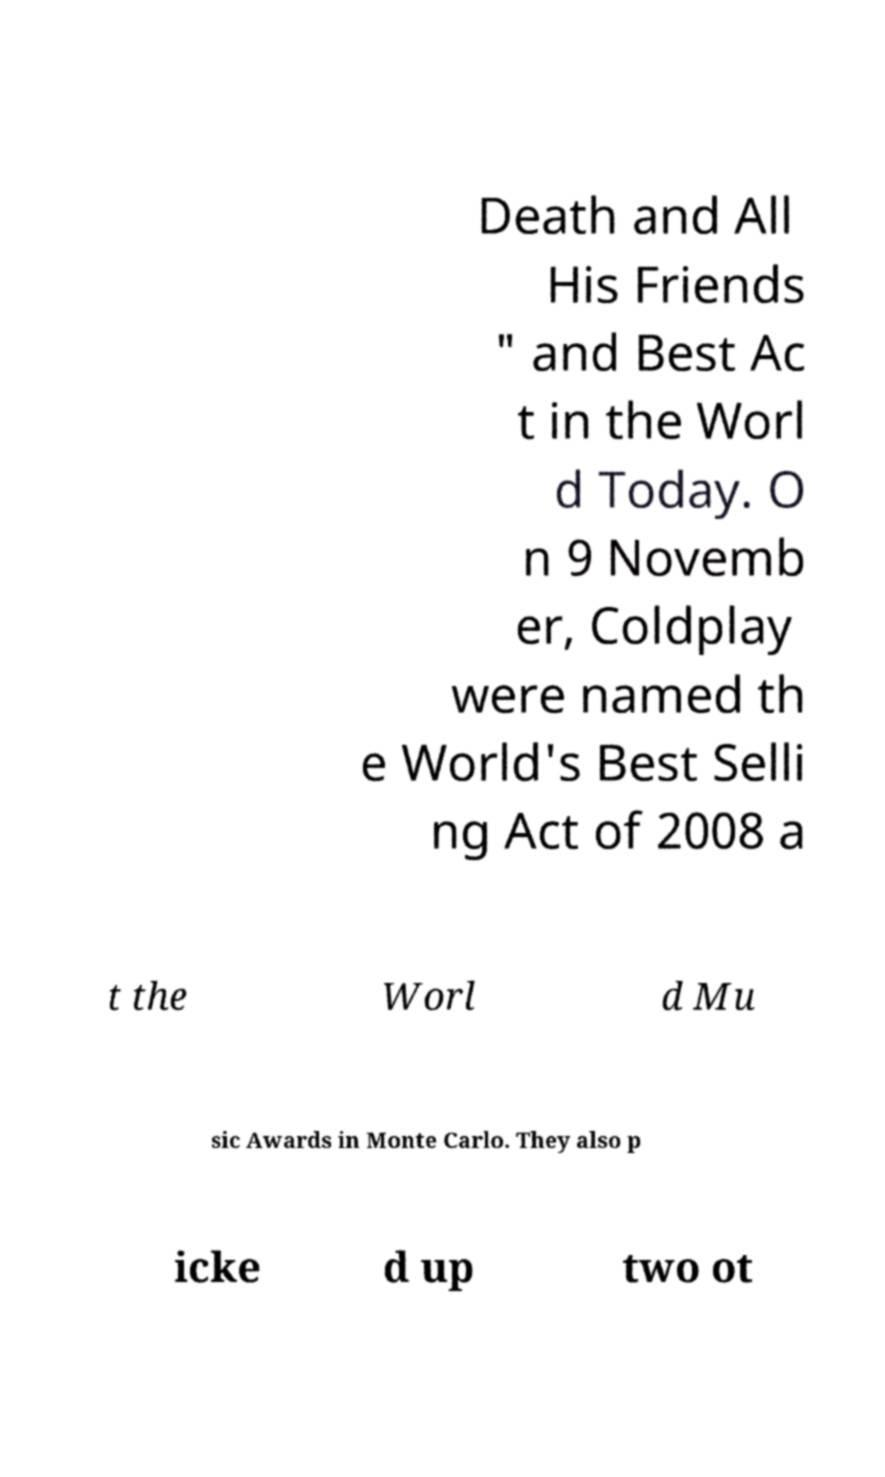Could you extract and type out the text from this image? Death and All His Friends " and Best Ac t in the Worl d Today. O n 9 Novemb er, Coldplay were named th e World's Best Selli ng Act of 2008 a t the Worl d Mu sic Awards in Monte Carlo. They also p icke d up two ot 